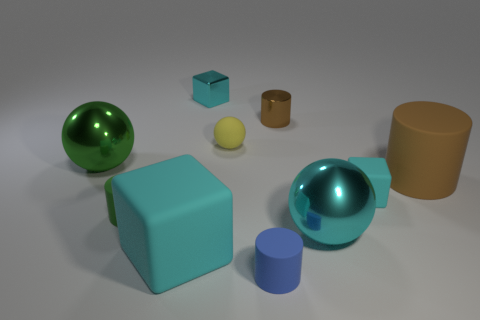The cyan thing that is behind the tiny green matte cylinder and in front of the cyan metal block has what shape? The object in question is a cube with a distinct cyan color. Its geometry is characterized by equal edges and six square faces, each at a right angle to its adjacent faces — a typical representation of a three-dimensional square. 